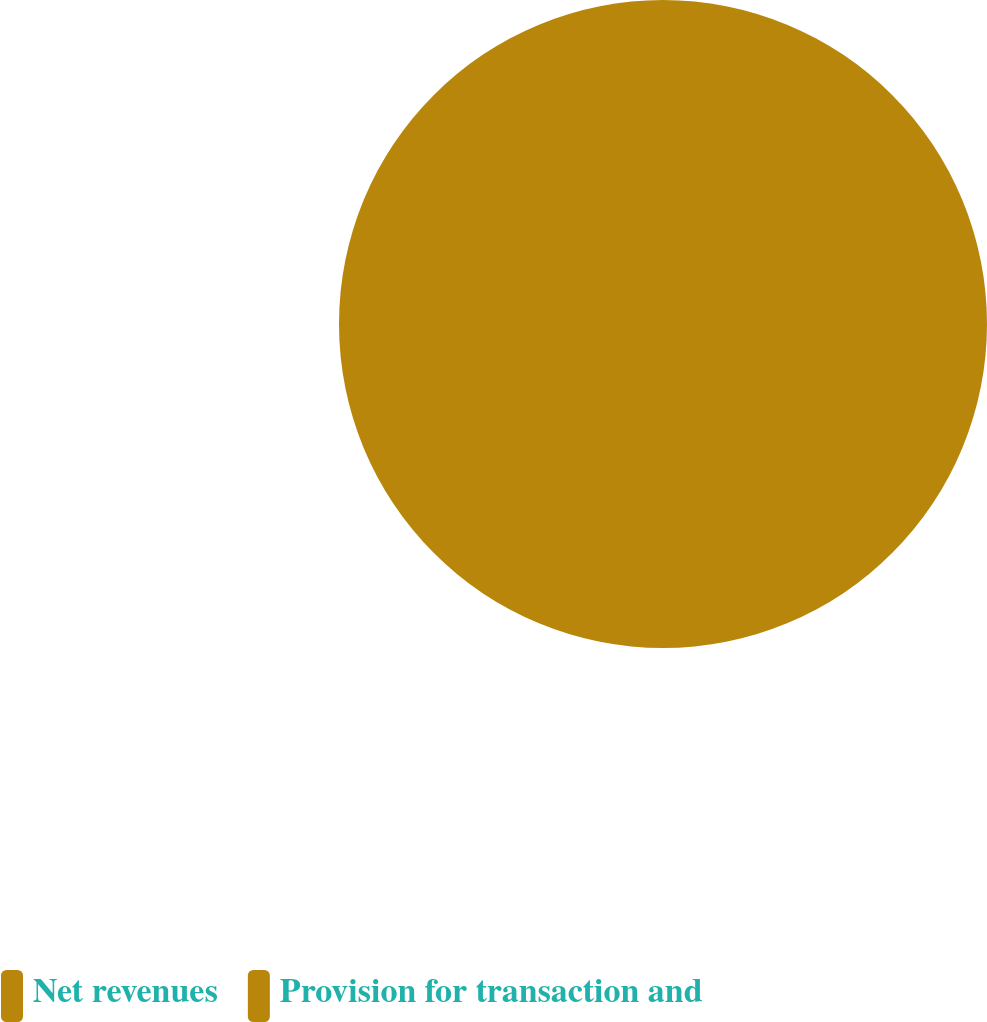Convert chart. <chart><loc_0><loc_0><loc_500><loc_500><pie_chart><fcel>Net revenues<fcel>Provision for transaction and<nl><fcel>100.0%<fcel>0.0%<nl></chart> 